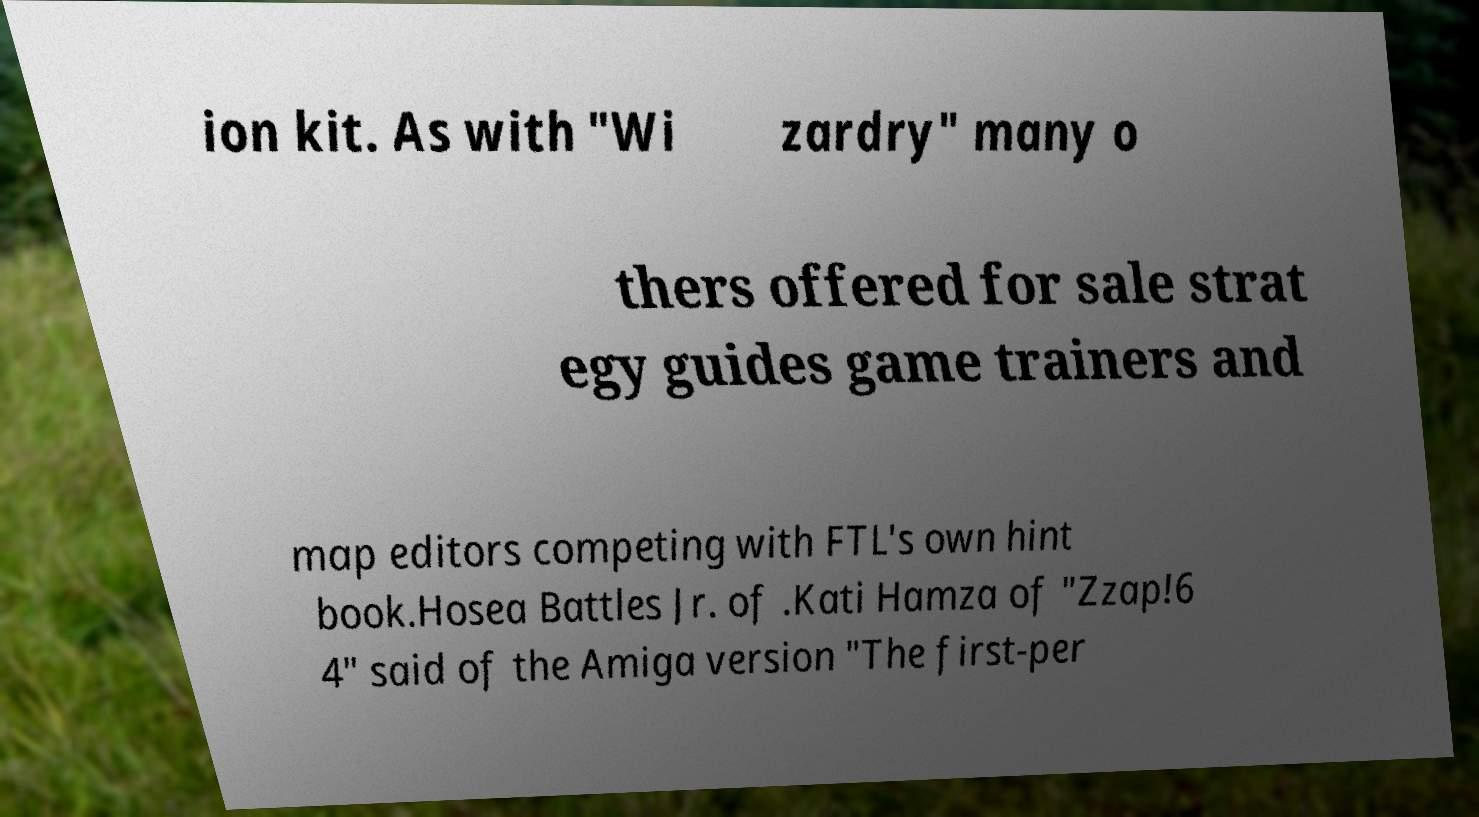Could you extract and type out the text from this image? ion kit. As with "Wi zardry" many o thers offered for sale strat egy guides game trainers and map editors competing with FTL's own hint book.Hosea Battles Jr. of .Kati Hamza of "Zzap!6 4" said of the Amiga version "The first-per 